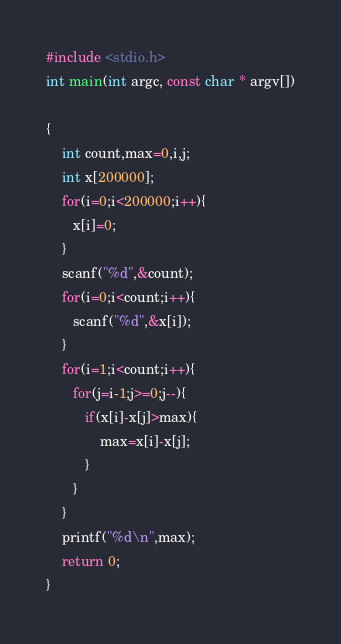Convert code to text. <code><loc_0><loc_0><loc_500><loc_500><_C_>#include <stdio.h>
int main(int argc, const char * argv[])

{
    int count,max=0,i,j;
    int x[200000];
    for(i=0;i<200000;i++){
       x[i]=0;
    }
    scanf("%d",&count);
    for(i=0;i<count;i++){
       scanf("%d",&x[i]);
    }
    for(i=1;i<count;i++){
       for(j=i-1;j>=0;j--){
          if(x[i]-x[j]>max){
              max=x[i]-x[j];
          }
       }
    }
    printf("%d\n",max);
    return 0;
}</code> 